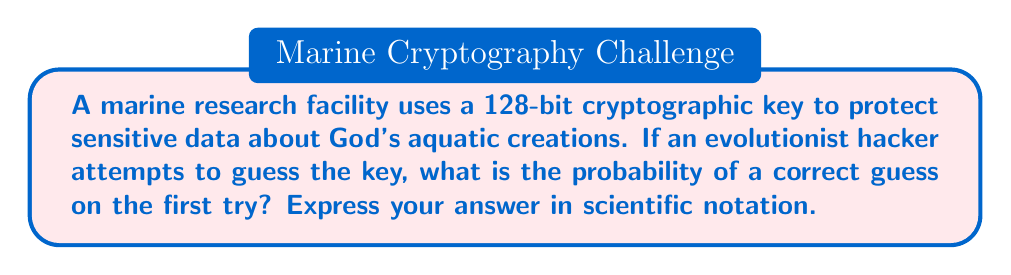Show me your answer to this math problem. Let's approach this step-by-step:

1) A 128-bit key means there are 2^128 possible combinations.

2) The probability of guessing the correct key is 1 divided by the total number of possible keys:

   $P(\text{correct guess}) = \frac{1}{2^{128}}$

3) To calculate this:
   
   $$\frac{1}{2^{128}} = 2^{-128}$$

4) Now, we need to convert this to scientific notation. 
   
   $2^{-128} \approx 3.4028 \times 10^{-39}$

5) This extremely small probability demonstrates the robustness of the cryptographic protection, showcasing the intricate design in our digital systems, much like the complexity we observe in God's aquatic creations.
Answer: $3.4028 \times 10^{-39}$ 